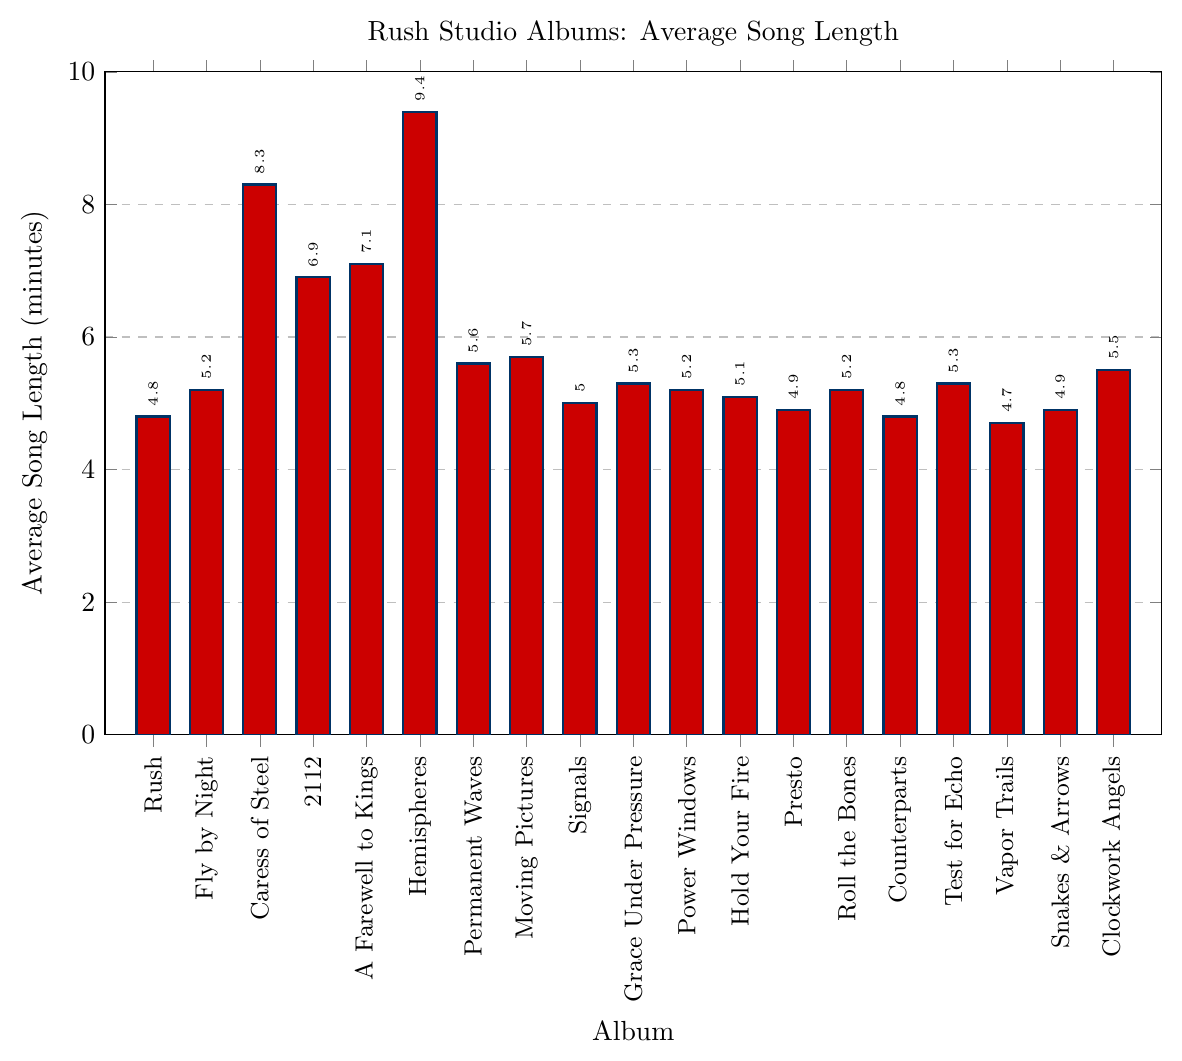Which album has the longest average song length? The bar representing Hemispheres is the tallest, indicating it has the longest average song length among all the albums.
Answer: Hemispheres Which album has the shortest average song length? The bar representing Vapor Trails is the shortest, showing it has the shortest average song length among the albums.
Answer: Vapor Trails How much longer is the average song length on Hemispheres compared to Rush? Hemispheres has an average song length of 9.4 minutes, while Rush has 4.8 minutes. The difference is calculated as 9.4 - 4.8 = 4.6 minutes.
Answer: 4.6 minutes What is the range of average song lengths across all albums? The longest average song length is 9.4 minutes (Hemispheres) and the shortest is 4.7 minutes (Vapor Trails). The range is 9.4 - 4.7 = 4.7 minutes.
Answer: 4.7 minutes How many albums have an average song length greater than 6 minutes? The albums with bars exceeding the 6-minute mark are Caress of Steel, 2112, A Farewell to Kings, and Hemispheres. Counting these albums gives us 4.
Answer: 4 albums What is the combined average song length of Fly by Night and Clockwork Angels? Fly by Night has an average length of 5.2 minutes and Clockwork Angels has 5.5 minutes. Summing these up: 5.2 + 5.5 = 10.7 minutes.
Answer: 10.7 minutes Compare the average song lengths between 2112 and Grace Under Pressure. Which album has the greater average song length and by how much? 2112 has an average length of 6.9 minutes, whereas Grace Under Pressure has 5.3 minutes. The difference is 6.9 - 5.3 = 1.6 minutes.
Answer: 2112 by 1.6 minutes What is the average song length for albums released before 1980 (Rush to Permanent Waves)? Rush (4.8), Fly by Night (5.2), Caress of Steel (8.3), 2112 (6.9), A Farewell to Kings (7.1), Hemispheres (9.4), and Permanent Waves (5.6). The average is (4.8 + 5.2 + 8.3 + 6.9 + 7.1 + 9.4 + 5.6) / 7 = 6.471.
Answer: Approximately 6.5 minutes Identify any albums with average song lengths between 5.0 and 5.5 minutes inclusive. The albums with bars between 5.0 and 5.5 are Fly by Night (5.2), Signals (5.0), Grace Under Pressure (5.3), Power Windows (5.2), Hold Your Fire (5.1), Roll the Bones (5.2), Test for Echo (5.3), and Clockwork Angels (5.5).
Answer: 8 albums Which album has an average song length closest to the overall average of all the albums? Calculating the overall average: (4.8 + 5.2 + 8.3 + 6.9 + 7.1 + 9.4 + 5.6 + 5.7 + 5.0 + 5.3 + 5.2 + 5.1 + 4.9 + 5.2 + 4.8 + 5.3 + 4.7 + 4.9 + 5.5) / 19 = 5.64. The album "Moving Pictures" has an average of 5.7, which is closest to 5.64.
Answer: Moving Pictures 